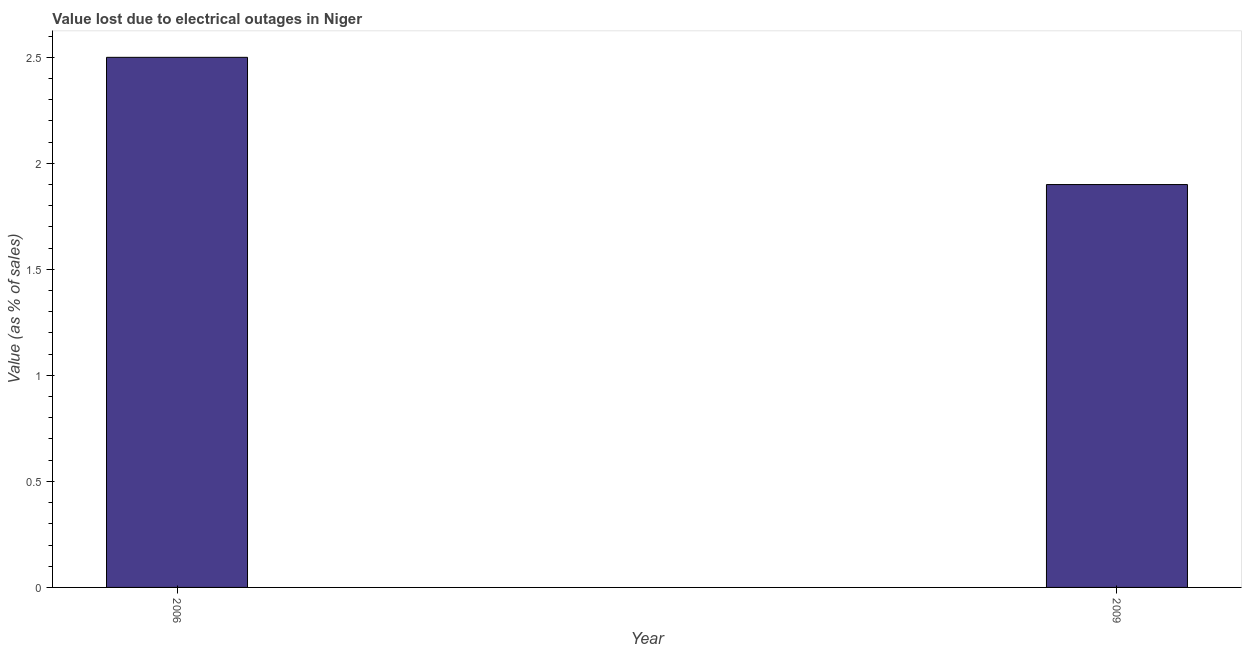Does the graph contain grids?
Your answer should be very brief. No. What is the title of the graph?
Your answer should be compact. Value lost due to electrical outages in Niger. What is the label or title of the X-axis?
Ensure brevity in your answer.  Year. What is the label or title of the Y-axis?
Provide a short and direct response. Value (as % of sales). In which year was the value lost due to electrical outages maximum?
Offer a terse response. 2006. What is the sum of the value lost due to electrical outages?
Provide a short and direct response. 4.4. What is the difference between the value lost due to electrical outages in 2006 and 2009?
Provide a short and direct response. 0.6. What is the average value lost due to electrical outages per year?
Give a very brief answer. 2.2. What is the median value lost due to electrical outages?
Your answer should be compact. 2.2. What is the ratio of the value lost due to electrical outages in 2006 to that in 2009?
Your answer should be compact. 1.32. In how many years, is the value lost due to electrical outages greater than the average value lost due to electrical outages taken over all years?
Give a very brief answer. 1. How many bars are there?
Provide a succinct answer. 2. Are the values on the major ticks of Y-axis written in scientific E-notation?
Your answer should be compact. No. What is the Value (as % of sales) in 2006?
Offer a very short reply. 2.5. What is the difference between the Value (as % of sales) in 2006 and 2009?
Ensure brevity in your answer.  0.6. What is the ratio of the Value (as % of sales) in 2006 to that in 2009?
Make the answer very short. 1.32. 